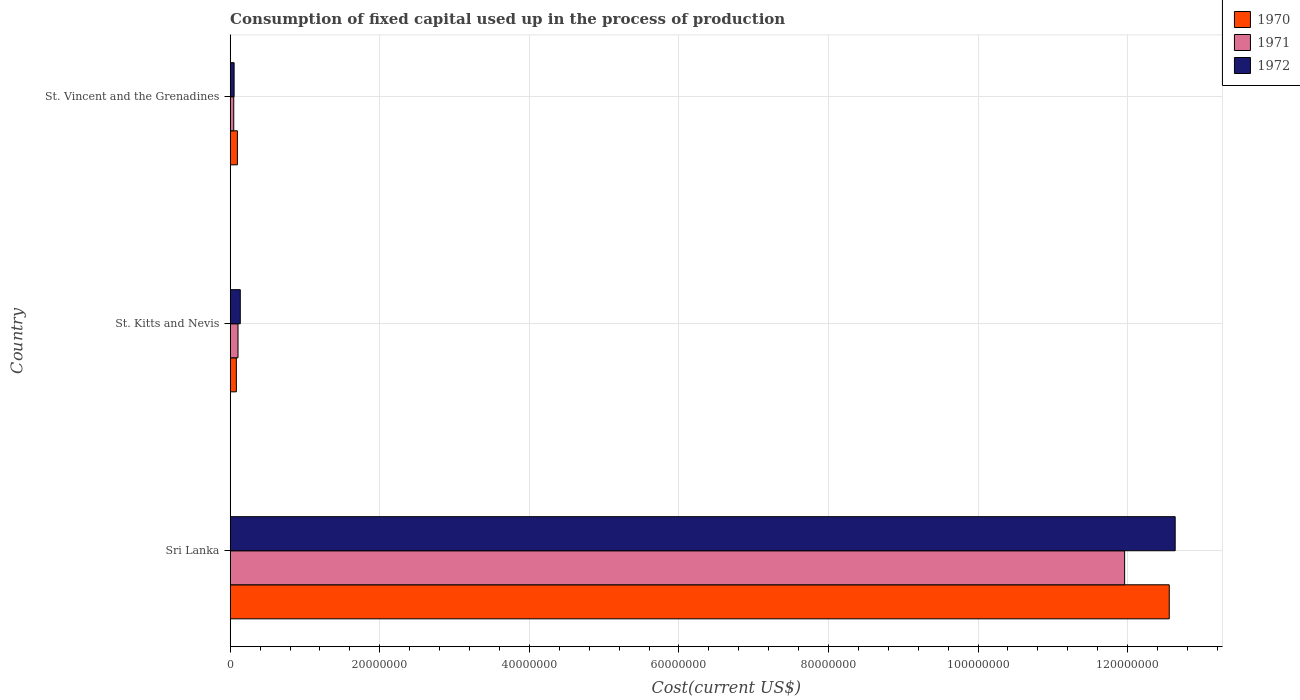How many groups of bars are there?
Make the answer very short. 3. Are the number of bars per tick equal to the number of legend labels?
Your answer should be very brief. Yes. Are the number of bars on each tick of the Y-axis equal?
Your answer should be compact. Yes. How many bars are there on the 2nd tick from the bottom?
Keep it short and to the point. 3. What is the label of the 2nd group of bars from the top?
Give a very brief answer. St. Kitts and Nevis. In how many cases, is the number of bars for a given country not equal to the number of legend labels?
Keep it short and to the point. 0. What is the amount consumed in the process of production in 1971 in St. Vincent and the Grenadines?
Offer a terse response. 4.77e+05. Across all countries, what is the maximum amount consumed in the process of production in 1970?
Offer a terse response. 1.26e+08. Across all countries, what is the minimum amount consumed in the process of production in 1970?
Make the answer very short. 8.25e+05. In which country was the amount consumed in the process of production in 1970 maximum?
Offer a terse response. Sri Lanka. In which country was the amount consumed in the process of production in 1972 minimum?
Keep it short and to the point. St. Vincent and the Grenadines. What is the total amount consumed in the process of production in 1970 in the graph?
Ensure brevity in your answer.  1.27e+08. What is the difference between the amount consumed in the process of production in 1970 in Sri Lanka and that in St. Kitts and Nevis?
Offer a terse response. 1.25e+08. What is the difference between the amount consumed in the process of production in 1972 in Sri Lanka and the amount consumed in the process of production in 1970 in St. Kitts and Nevis?
Your response must be concise. 1.26e+08. What is the average amount consumed in the process of production in 1971 per country?
Your answer should be very brief. 4.04e+07. What is the difference between the amount consumed in the process of production in 1972 and amount consumed in the process of production in 1971 in Sri Lanka?
Keep it short and to the point. 6.76e+06. In how many countries, is the amount consumed in the process of production in 1970 greater than 104000000 US$?
Provide a succinct answer. 1. What is the ratio of the amount consumed in the process of production in 1970 in Sri Lanka to that in St. Kitts and Nevis?
Your response must be concise. 152.13. Is the difference between the amount consumed in the process of production in 1972 in Sri Lanka and St. Kitts and Nevis greater than the difference between the amount consumed in the process of production in 1971 in Sri Lanka and St. Kitts and Nevis?
Give a very brief answer. Yes. What is the difference between the highest and the second highest amount consumed in the process of production in 1971?
Provide a succinct answer. 1.19e+08. What is the difference between the highest and the lowest amount consumed in the process of production in 1970?
Provide a short and direct response. 1.25e+08. Is the sum of the amount consumed in the process of production in 1971 in St. Kitts and Nevis and St. Vincent and the Grenadines greater than the maximum amount consumed in the process of production in 1970 across all countries?
Provide a short and direct response. No. What does the 1st bar from the top in St. Kitts and Nevis represents?
Your answer should be very brief. 1972. What does the 1st bar from the bottom in St. Kitts and Nevis represents?
Offer a terse response. 1970. How many bars are there?
Provide a short and direct response. 9. What is the difference between two consecutive major ticks on the X-axis?
Your response must be concise. 2.00e+07. Are the values on the major ticks of X-axis written in scientific E-notation?
Your answer should be very brief. No. Does the graph contain any zero values?
Ensure brevity in your answer.  No. What is the title of the graph?
Offer a terse response. Consumption of fixed capital used up in the process of production. Does "2001" appear as one of the legend labels in the graph?
Offer a very short reply. No. What is the label or title of the X-axis?
Your response must be concise. Cost(current US$). What is the label or title of the Y-axis?
Give a very brief answer. Country. What is the Cost(current US$) in 1970 in Sri Lanka?
Your response must be concise. 1.26e+08. What is the Cost(current US$) in 1971 in Sri Lanka?
Offer a terse response. 1.20e+08. What is the Cost(current US$) in 1972 in Sri Lanka?
Offer a very short reply. 1.26e+08. What is the Cost(current US$) in 1970 in St. Kitts and Nevis?
Keep it short and to the point. 8.25e+05. What is the Cost(current US$) in 1971 in St. Kitts and Nevis?
Your response must be concise. 1.05e+06. What is the Cost(current US$) in 1972 in St. Kitts and Nevis?
Provide a short and direct response. 1.35e+06. What is the Cost(current US$) in 1970 in St. Vincent and the Grenadines?
Your answer should be very brief. 9.66e+05. What is the Cost(current US$) of 1971 in St. Vincent and the Grenadines?
Ensure brevity in your answer.  4.77e+05. What is the Cost(current US$) of 1972 in St. Vincent and the Grenadines?
Keep it short and to the point. 5.25e+05. Across all countries, what is the maximum Cost(current US$) in 1970?
Provide a short and direct response. 1.26e+08. Across all countries, what is the maximum Cost(current US$) of 1971?
Give a very brief answer. 1.20e+08. Across all countries, what is the maximum Cost(current US$) of 1972?
Provide a short and direct response. 1.26e+08. Across all countries, what is the minimum Cost(current US$) in 1970?
Give a very brief answer. 8.25e+05. Across all countries, what is the minimum Cost(current US$) of 1971?
Provide a short and direct response. 4.77e+05. Across all countries, what is the minimum Cost(current US$) of 1972?
Offer a very short reply. 5.25e+05. What is the total Cost(current US$) of 1970 in the graph?
Ensure brevity in your answer.  1.27e+08. What is the total Cost(current US$) in 1971 in the graph?
Your response must be concise. 1.21e+08. What is the total Cost(current US$) in 1972 in the graph?
Ensure brevity in your answer.  1.28e+08. What is the difference between the Cost(current US$) of 1970 in Sri Lanka and that in St. Kitts and Nevis?
Make the answer very short. 1.25e+08. What is the difference between the Cost(current US$) of 1971 in Sri Lanka and that in St. Kitts and Nevis?
Provide a succinct answer. 1.19e+08. What is the difference between the Cost(current US$) in 1972 in Sri Lanka and that in St. Kitts and Nevis?
Your answer should be very brief. 1.25e+08. What is the difference between the Cost(current US$) of 1970 in Sri Lanka and that in St. Vincent and the Grenadines?
Keep it short and to the point. 1.25e+08. What is the difference between the Cost(current US$) of 1971 in Sri Lanka and that in St. Vincent and the Grenadines?
Offer a very short reply. 1.19e+08. What is the difference between the Cost(current US$) of 1972 in Sri Lanka and that in St. Vincent and the Grenadines?
Your answer should be compact. 1.26e+08. What is the difference between the Cost(current US$) in 1970 in St. Kitts and Nevis and that in St. Vincent and the Grenadines?
Give a very brief answer. -1.41e+05. What is the difference between the Cost(current US$) of 1971 in St. Kitts and Nevis and that in St. Vincent and the Grenadines?
Ensure brevity in your answer.  5.71e+05. What is the difference between the Cost(current US$) in 1972 in St. Kitts and Nevis and that in St. Vincent and the Grenadines?
Your response must be concise. 8.24e+05. What is the difference between the Cost(current US$) of 1970 in Sri Lanka and the Cost(current US$) of 1971 in St. Kitts and Nevis?
Your answer should be very brief. 1.25e+08. What is the difference between the Cost(current US$) in 1970 in Sri Lanka and the Cost(current US$) in 1972 in St. Kitts and Nevis?
Your response must be concise. 1.24e+08. What is the difference between the Cost(current US$) in 1971 in Sri Lanka and the Cost(current US$) in 1972 in St. Kitts and Nevis?
Your response must be concise. 1.18e+08. What is the difference between the Cost(current US$) of 1970 in Sri Lanka and the Cost(current US$) of 1971 in St. Vincent and the Grenadines?
Give a very brief answer. 1.25e+08. What is the difference between the Cost(current US$) of 1970 in Sri Lanka and the Cost(current US$) of 1972 in St. Vincent and the Grenadines?
Provide a short and direct response. 1.25e+08. What is the difference between the Cost(current US$) of 1971 in Sri Lanka and the Cost(current US$) of 1972 in St. Vincent and the Grenadines?
Provide a succinct answer. 1.19e+08. What is the difference between the Cost(current US$) of 1970 in St. Kitts and Nevis and the Cost(current US$) of 1971 in St. Vincent and the Grenadines?
Your response must be concise. 3.49e+05. What is the difference between the Cost(current US$) in 1970 in St. Kitts and Nevis and the Cost(current US$) in 1972 in St. Vincent and the Grenadines?
Provide a succinct answer. 3.00e+05. What is the difference between the Cost(current US$) of 1971 in St. Kitts and Nevis and the Cost(current US$) of 1972 in St. Vincent and the Grenadines?
Give a very brief answer. 5.22e+05. What is the average Cost(current US$) of 1970 per country?
Make the answer very short. 4.25e+07. What is the average Cost(current US$) of 1971 per country?
Ensure brevity in your answer.  4.04e+07. What is the average Cost(current US$) in 1972 per country?
Offer a terse response. 4.27e+07. What is the difference between the Cost(current US$) in 1970 and Cost(current US$) in 1971 in Sri Lanka?
Give a very brief answer. 5.97e+06. What is the difference between the Cost(current US$) of 1970 and Cost(current US$) of 1972 in Sri Lanka?
Ensure brevity in your answer.  -7.92e+05. What is the difference between the Cost(current US$) of 1971 and Cost(current US$) of 1972 in Sri Lanka?
Your response must be concise. -6.76e+06. What is the difference between the Cost(current US$) in 1970 and Cost(current US$) in 1971 in St. Kitts and Nevis?
Offer a terse response. -2.22e+05. What is the difference between the Cost(current US$) of 1970 and Cost(current US$) of 1972 in St. Kitts and Nevis?
Keep it short and to the point. -5.24e+05. What is the difference between the Cost(current US$) in 1971 and Cost(current US$) in 1972 in St. Kitts and Nevis?
Offer a terse response. -3.02e+05. What is the difference between the Cost(current US$) of 1970 and Cost(current US$) of 1971 in St. Vincent and the Grenadines?
Keep it short and to the point. 4.89e+05. What is the difference between the Cost(current US$) in 1970 and Cost(current US$) in 1972 in St. Vincent and the Grenadines?
Provide a short and direct response. 4.40e+05. What is the difference between the Cost(current US$) of 1971 and Cost(current US$) of 1972 in St. Vincent and the Grenadines?
Your answer should be very brief. -4.89e+04. What is the ratio of the Cost(current US$) in 1970 in Sri Lanka to that in St. Kitts and Nevis?
Ensure brevity in your answer.  152.13. What is the ratio of the Cost(current US$) of 1971 in Sri Lanka to that in St. Kitts and Nevis?
Ensure brevity in your answer.  114.21. What is the ratio of the Cost(current US$) in 1972 in Sri Lanka to that in St. Kitts and Nevis?
Your response must be concise. 93.65. What is the ratio of the Cost(current US$) in 1970 in Sri Lanka to that in St. Vincent and the Grenadines?
Offer a very short reply. 130. What is the ratio of the Cost(current US$) of 1971 in Sri Lanka to that in St. Vincent and the Grenadines?
Your answer should be very brief. 250.94. What is the ratio of the Cost(current US$) of 1972 in Sri Lanka to that in St. Vincent and the Grenadines?
Keep it short and to the point. 240.46. What is the ratio of the Cost(current US$) of 1970 in St. Kitts and Nevis to that in St. Vincent and the Grenadines?
Make the answer very short. 0.85. What is the ratio of the Cost(current US$) in 1971 in St. Kitts and Nevis to that in St. Vincent and the Grenadines?
Ensure brevity in your answer.  2.2. What is the ratio of the Cost(current US$) in 1972 in St. Kitts and Nevis to that in St. Vincent and the Grenadines?
Your answer should be very brief. 2.57. What is the difference between the highest and the second highest Cost(current US$) of 1970?
Provide a short and direct response. 1.25e+08. What is the difference between the highest and the second highest Cost(current US$) of 1971?
Your answer should be very brief. 1.19e+08. What is the difference between the highest and the second highest Cost(current US$) in 1972?
Make the answer very short. 1.25e+08. What is the difference between the highest and the lowest Cost(current US$) of 1970?
Make the answer very short. 1.25e+08. What is the difference between the highest and the lowest Cost(current US$) of 1971?
Give a very brief answer. 1.19e+08. What is the difference between the highest and the lowest Cost(current US$) in 1972?
Your answer should be compact. 1.26e+08. 